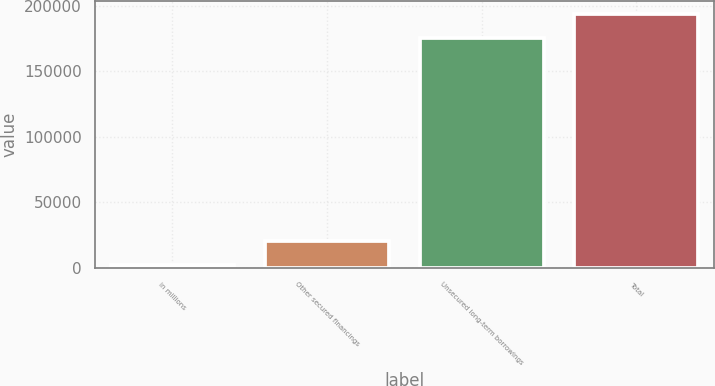Convert chart. <chart><loc_0><loc_0><loc_500><loc_500><bar_chart><fcel>in millions<fcel>Other secured financings<fcel>Unsecured long-term borrowings<fcel>Total<nl><fcel>2015<fcel>20407.7<fcel>175422<fcel>193815<nl></chart> 